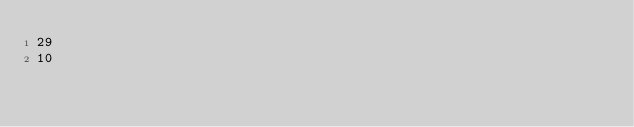Convert code to text. <code><loc_0><loc_0><loc_500><loc_500><_SQL_>29
10</code> 